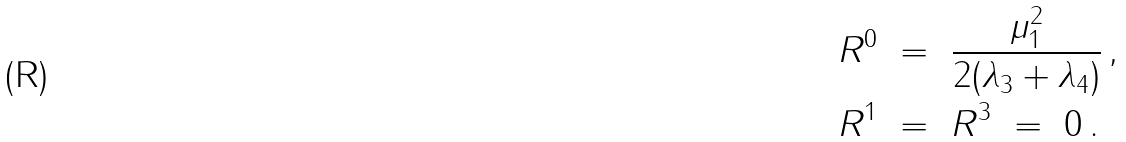<formula> <loc_0><loc_0><loc_500><loc_500>R ^ { 0 } \ & = \ \frac { \mu _ { 1 } ^ { 2 } } { 2 ( \lambda _ { 3 } + \lambda _ { 4 } ) } \, , \\ R ^ { 1 } \ & = \ R ^ { 3 } \ = \ 0 \, .</formula> 